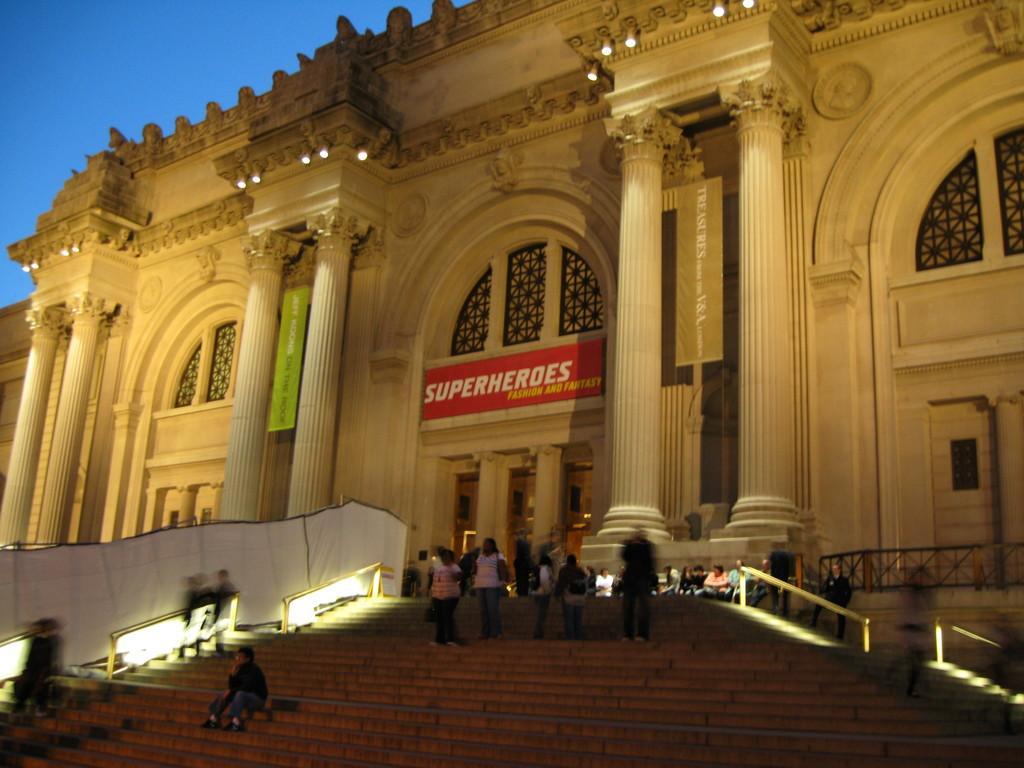Describe this image in one or two sentences. In this picture I can see the steps in front, on which there are number of people and I see the railings on both the sides. In the middle of this picture I see a building on which there are lights and I see boards on which there is something written. In the background I see the sky. 